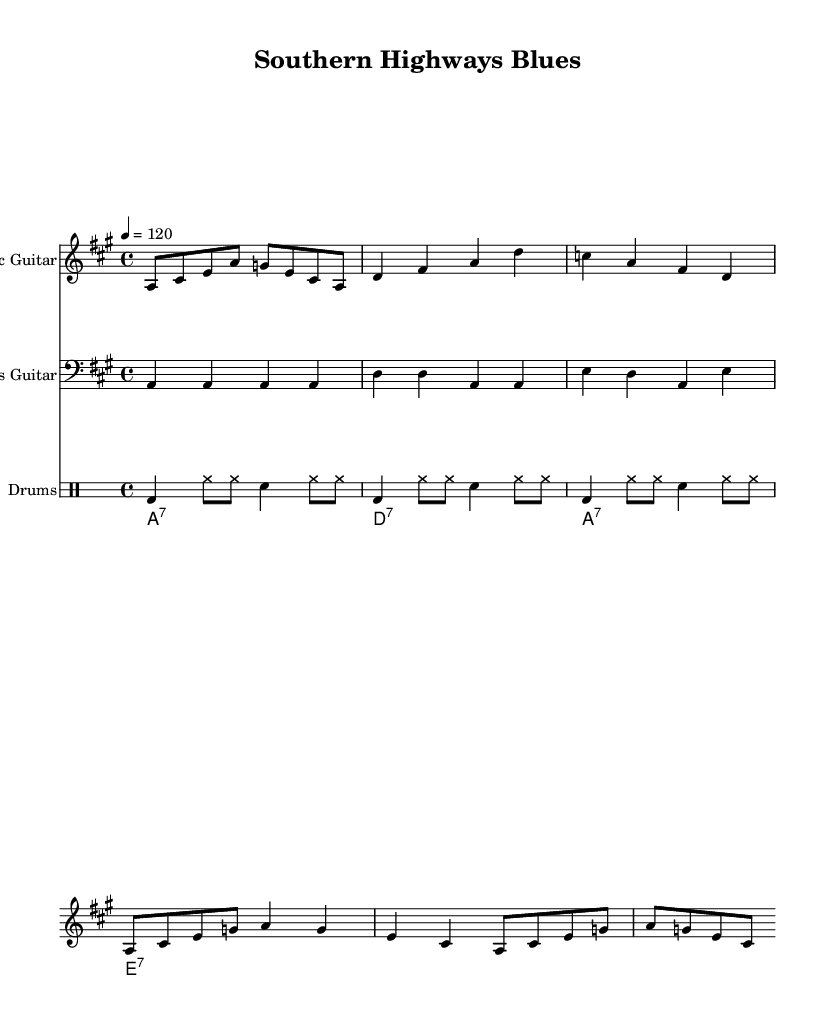What is the key signature of this music? The key signature is indicated by the sharps or flats at the beginning of the staff. In this case, the music is in A major, which has three sharps (F#, C#, and G#).
Answer: A major What is the time signature of this music? The time signature is shown at the beginning of the staff, indicating how many beats are in each measure. Here, the time signature is 4/4, which means there are four beats per measure.
Answer: 4/4 What is the tempo marking of this music? The tempo is indicated by a number with a note value. In the music, it is marked as 4 = 120, which means the quarter note gets 120 beats per minute.
Answer: 120 What instrument plays the highest notes? To determine which part plays the highest notes, you look at the treble clef staff. The electric guitar part is positioned on the clef that is used for higher pitch notes.
Answer: Electric Guitar How many measures are in the electric guitar part? To find the number of measures, you count the vertical bar lines that separate the measures in the electric guitar section. Counting those reveals there are eight measures.
Answer: Eight What chords are used in the organ accompaniment? The chords are indicated by symbols above the staff. In the organ part, the chords shown are A7, D7, A7, and E7. This sequence is reflective of common blues progressions.
Answer: A7, D7, E7 What rhythmic pattern is used in the drum part? The drum part primarily consists of bass drum hits and hi-hat patterns that repeat, creating a steady rhythmic backdrop for the song. The pattern is characterized by alternating between bass and snare with hi-hats.
Answer: Steady rhythmic backdrop 